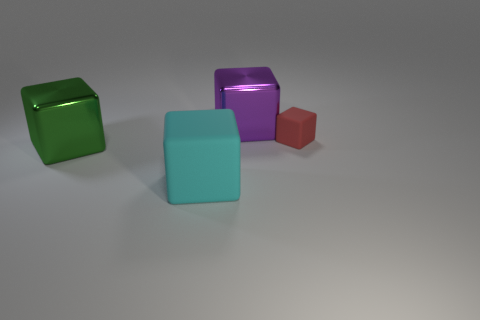Subtract 1 cubes. How many cubes are left? 3 Add 2 big shiny things. How many objects exist? 6 Add 4 green blocks. How many green blocks exist? 5 Subtract 0 blue cubes. How many objects are left? 4 Subtract all small green blocks. Subtract all large green metallic objects. How many objects are left? 3 Add 1 large things. How many large things are left? 4 